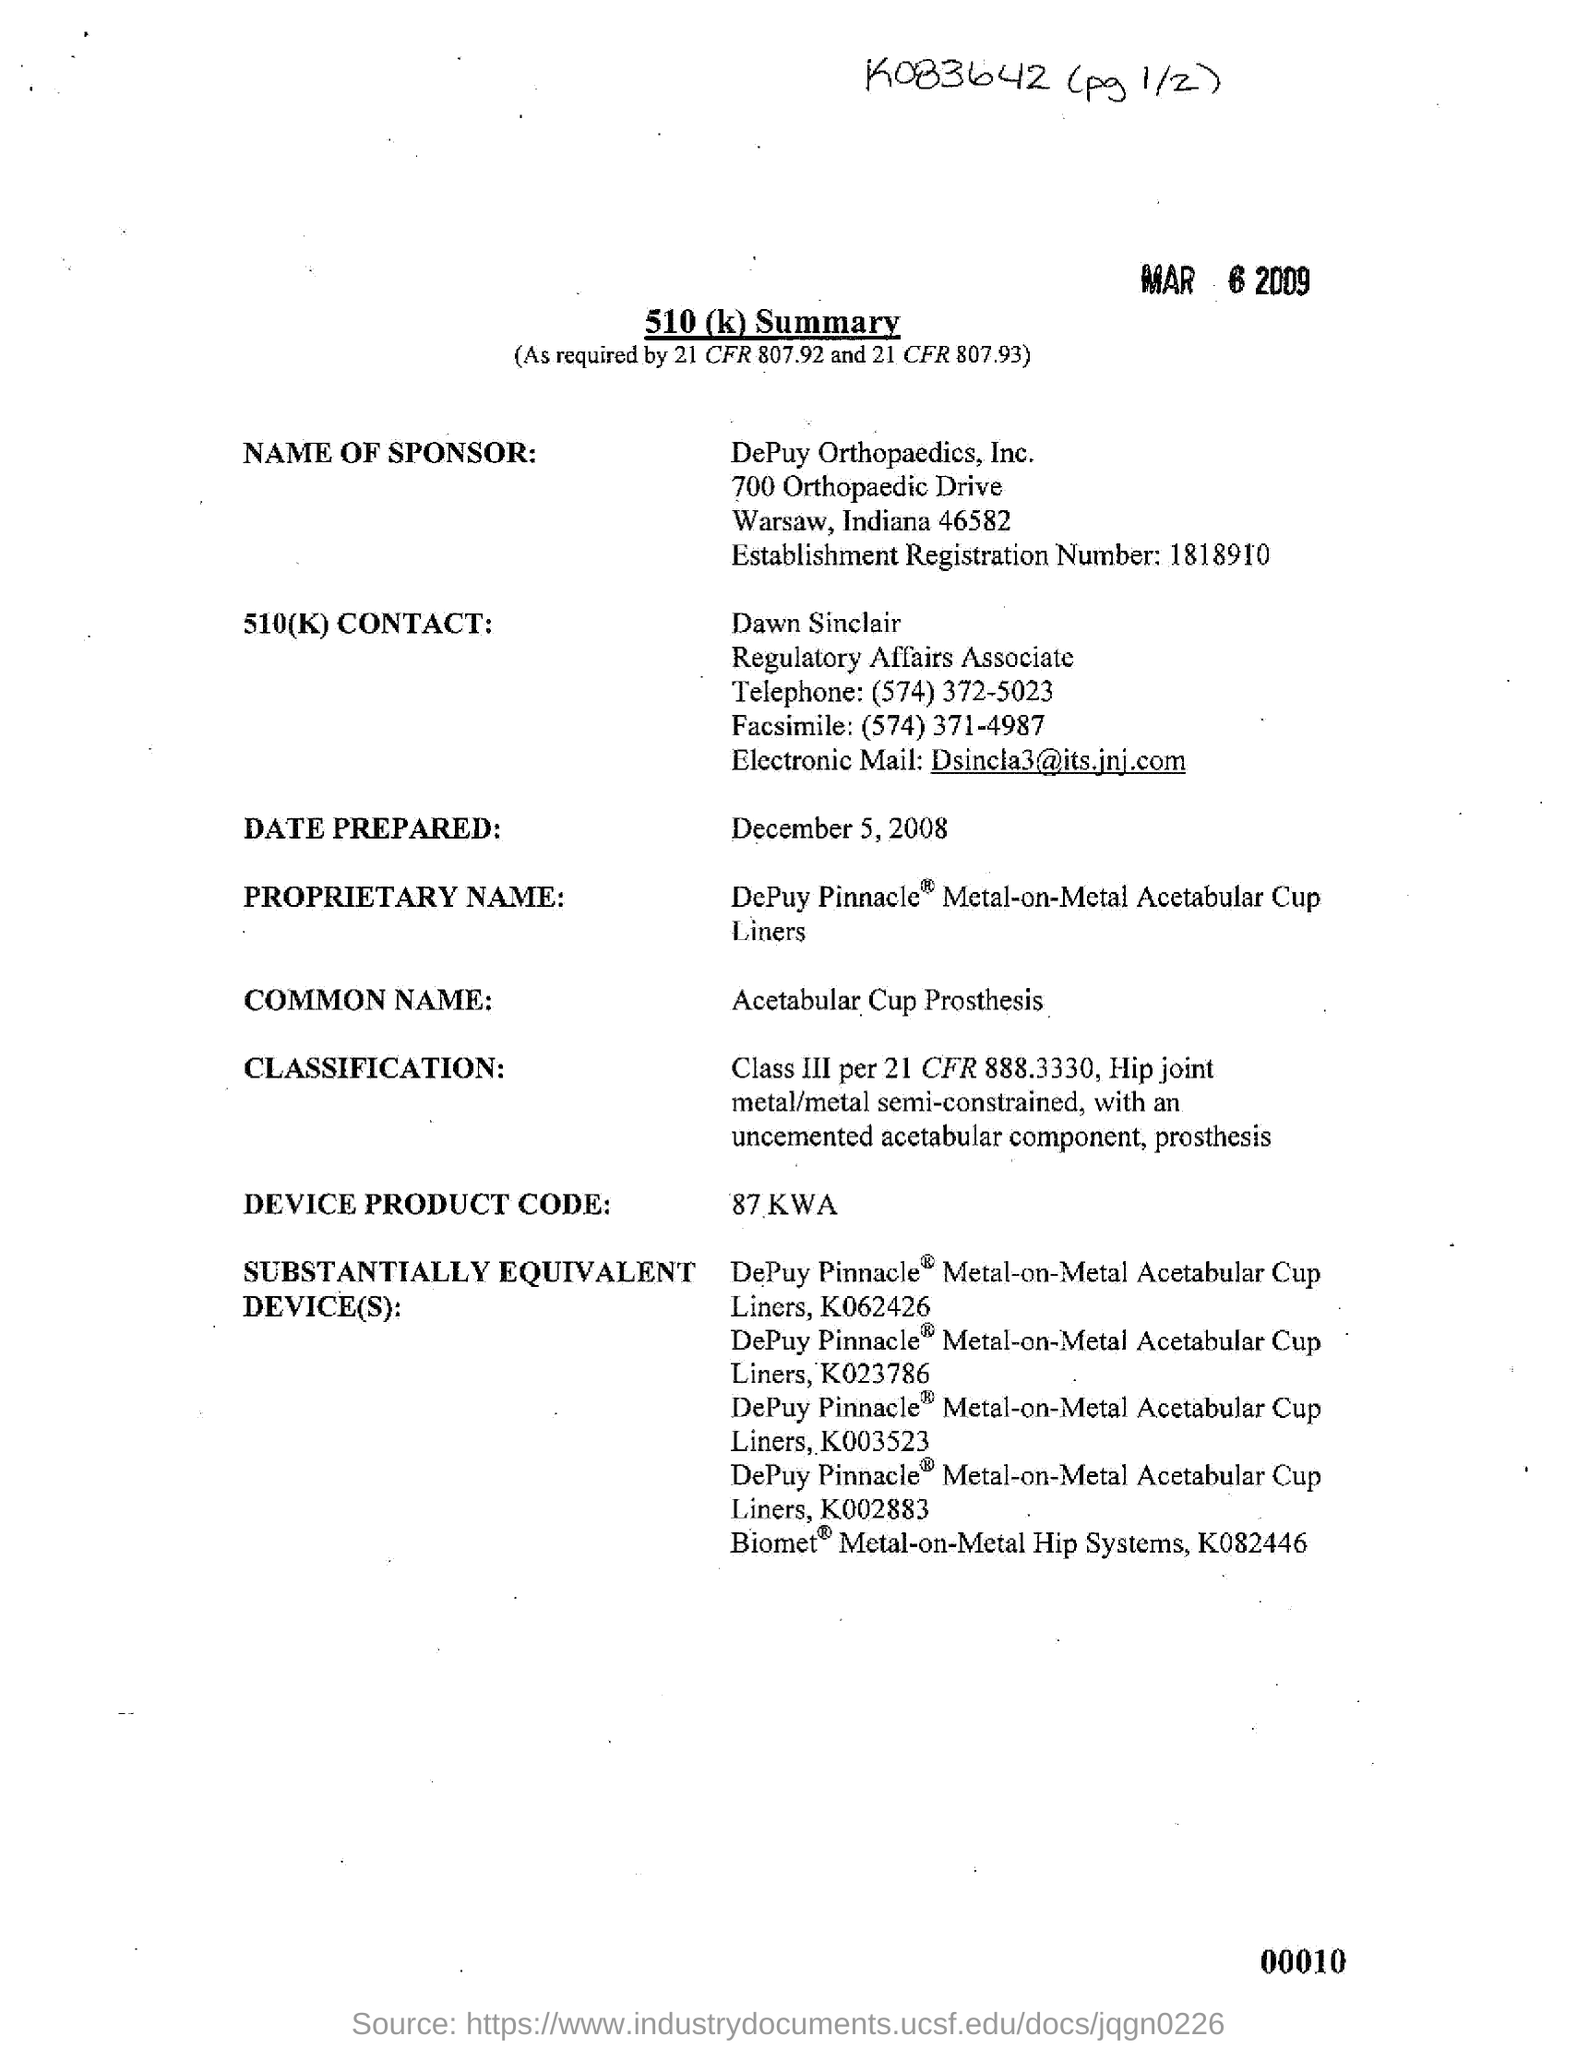What is the establishment registration number ?
Provide a short and direct response. 1818910. What is the date prepared ?
Offer a very short reply. December 5, 2008. In which state is depuy orthopaedics, inc. located?
Offer a very short reply. Indiana. What is the telephone number of dawn sinclair?
Your response must be concise. (574) 372-5023. What is the facsimile number ?
Offer a very short reply. (574) 371-4987. What is the common name ?
Your answer should be very brief. Acetabular Cup Prosthesis. 